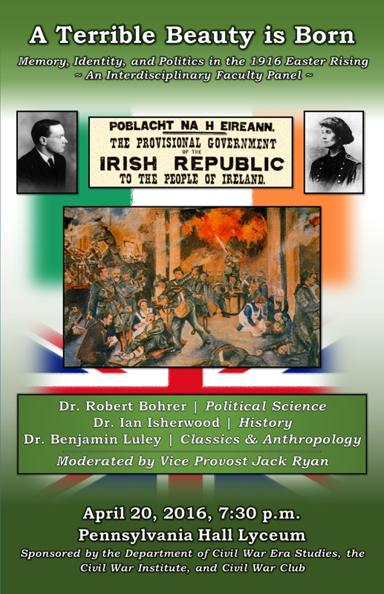What can we learn from the artwork depicted on the poster? The artwork vividly portrays the intensity and chaos of the Easter Rising. Through its dynamic composition and emotive portrayals, it captures the fervor and the dramatic impact of the uprising on the participants and the national consciousness. Studying such representations can provide insights into how art serves as a historical document and a tool of political expression, reflecting and shaping public memory. 